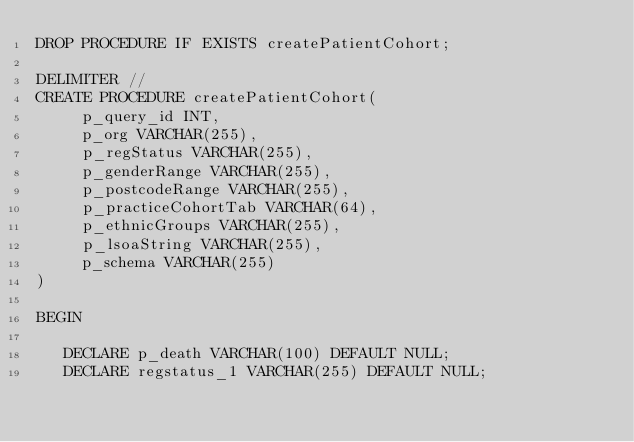Convert code to text. <code><loc_0><loc_0><loc_500><loc_500><_SQL_>DROP PROCEDURE IF EXISTS createPatientCohort;

DELIMITER //
CREATE PROCEDURE createPatientCohort(
     p_query_id INT,
     p_org VARCHAR(255),
     p_regStatus VARCHAR(255),
     p_genderRange VARCHAR(255),
     p_postcodeRange VARCHAR(255),
     p_practiceCohortTab VARCHAR(64),
     p_ethnicGroups VARCHAR(255), 
     p_lsoaString VARCHAR(255), 
     p_schema VARCHAR(255)
)

BEGIN

   DECLARE p_death VARCHAR(100) DEFAULT NULL;
   DECLARE regstatus_1 VARCHAR(255) DEFAULT NULL;</code> 